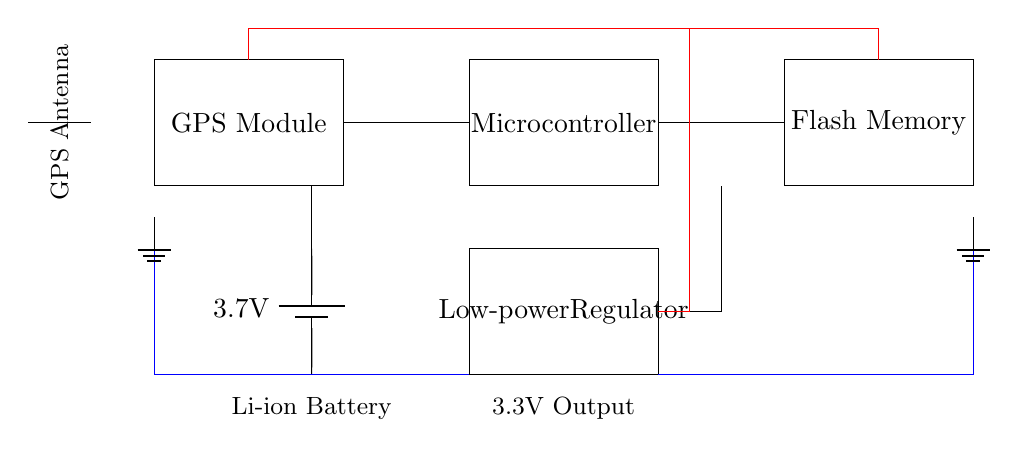What is the type of battery used in this circuit? The circuit diagram shows a single battery labeled as a Lithium-ion battery, indicated by the notation of a battery symbol with a voltage of 3.7 volts.
Answer: Lithium-ion What is the function of the low-power regulator? The low-power regulator in the circuit converts the battery voltage down to an appropriate level, specifically 3.3 volts, which is needed by the components such as the microcontroller and memory.
Answer: Regulate voltage How many main components are in the circuit? There are five main components visible in the circuit diagram: the GPS module, microcontroller, low-power regulator, flash memory, and battery.
Answer: Five What is the output voltage of the regulator? The output voltage of the low-power regulator is specified to be 3.3 volts, which is shown in the circuit diagram as labeling on the component.
Answer: 3.3 volts Where is the GPS antenna located in the circuit? The GPS antenna is represented in the circuit as an antenna symbol drawn to the left of the GPS module, indicating its connection to the module for signal reception.
Answer: Left of GPS module What does the memory component store? The flash memory component in the circuit is used to store GPS data, which is critical for tracking locations and maintaining a record of historical church locations visited.
Answer: GPS data How is the ground connected in this circuit? The ground connections are indicated with ground symbols, showing a connection from the battery and other components to a common ground point, which helps in maintaining a reference voltage throughout the circuit.
Answer: Common ground 